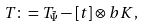<formula> <loc_0><loc_0><loc_500><loc_500>T \colon = T _ { \tilde { \Psi } } - [ t ] \otimes b K ,</formula> 